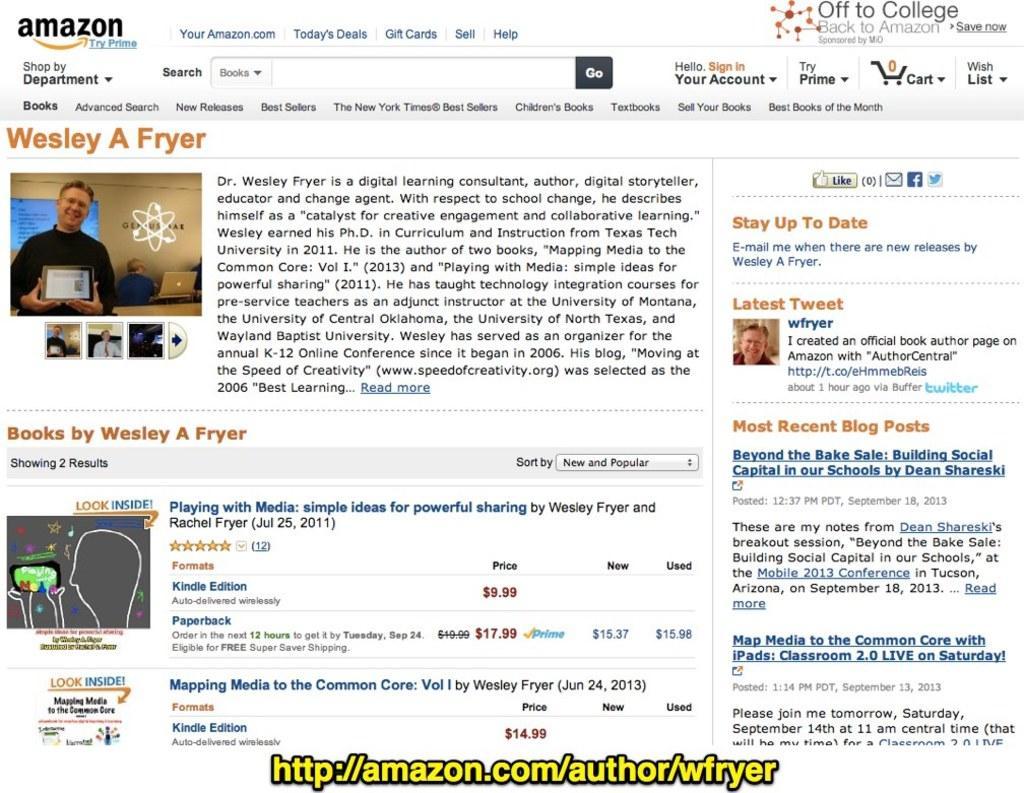In one or two sentences, can you explain what this image depicts? There is a screenshot. There are images and matter is written. There is an url at the bottom in yellow color. 